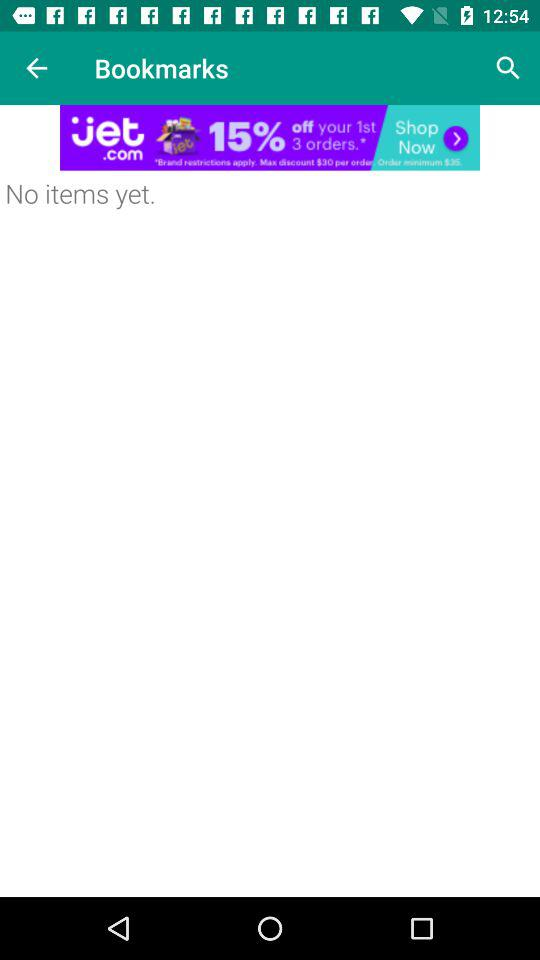How many items are there in bookmarks? There are no items in bookmarks. 